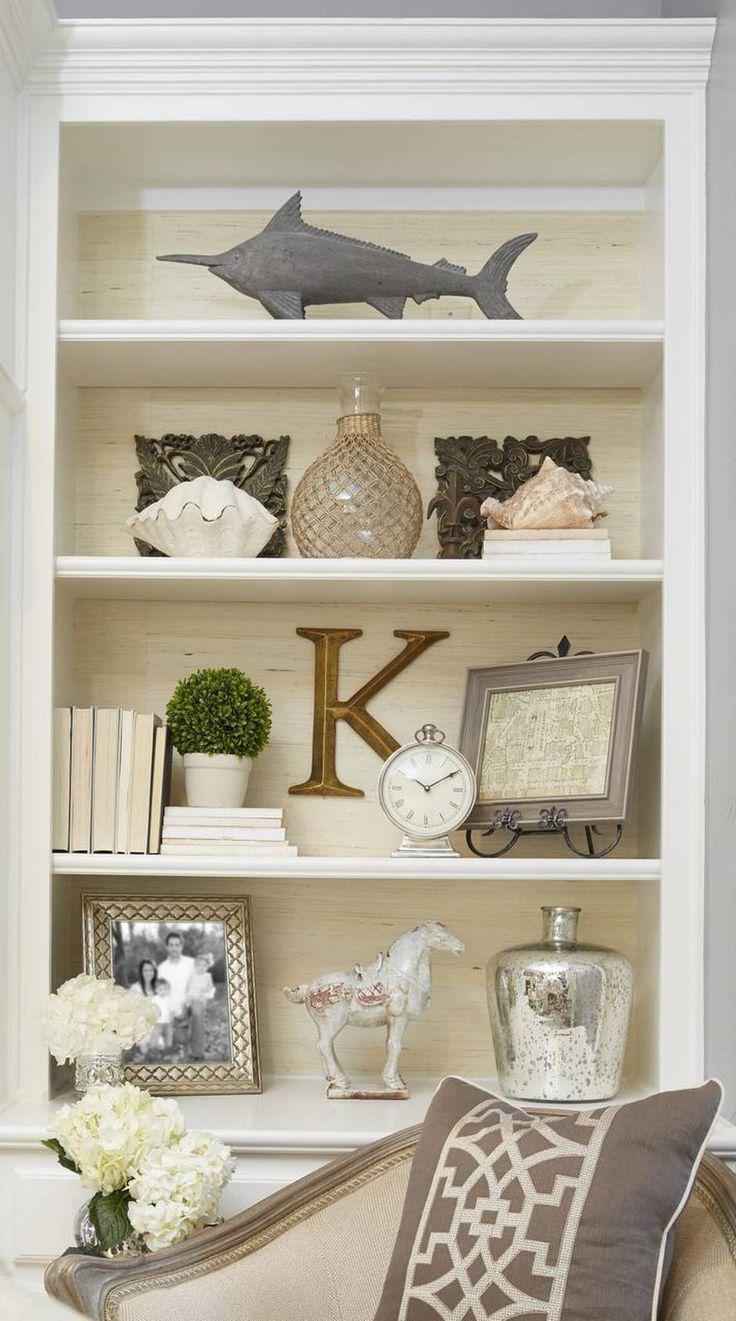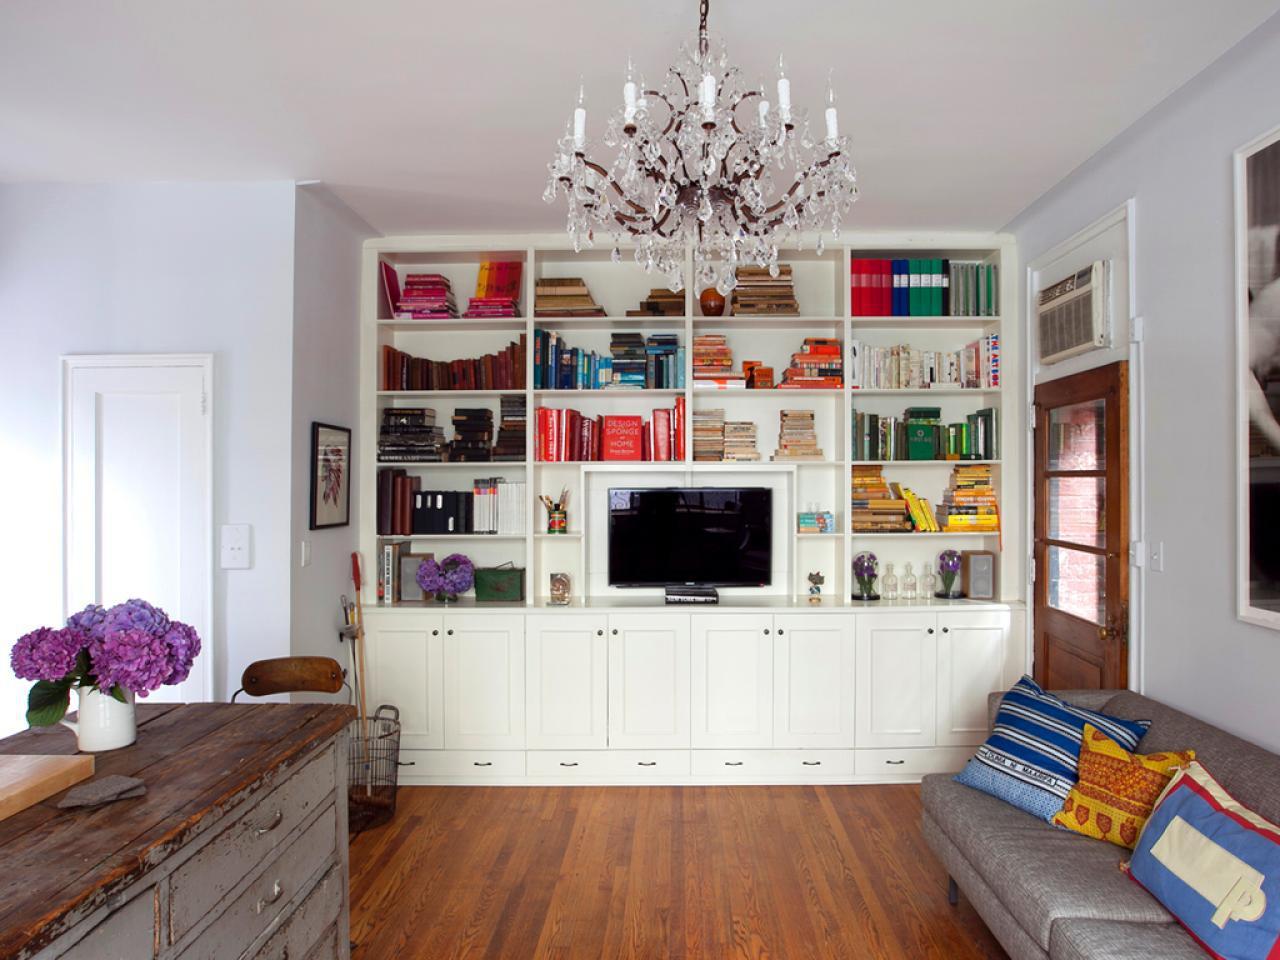The first image is the image on the left, the second image is the image on the right. Examine the images to the left and right. Is the description "In one image, artwork is hung on the center front of a white built-in shelving unit." accurate? Answer yes or no. No. The first image is the image on the left, the second image is the image on the right. Considering the images on both sides, is "One image is a room with a chandelier and a white bookcase that fills a wall." valid? Answer yes or no. Yes. 